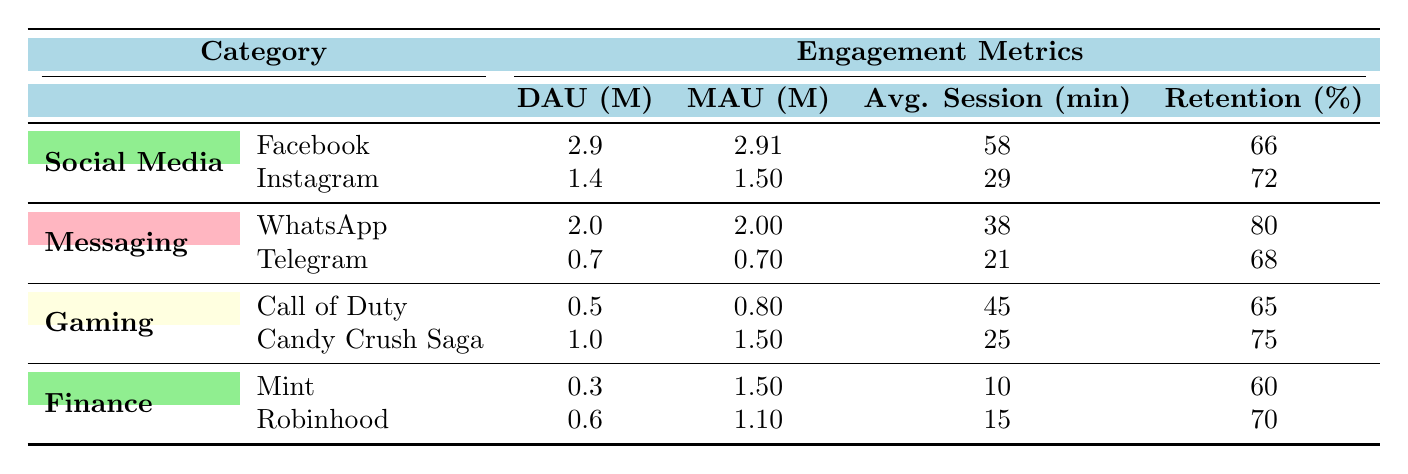What app has the highest Daily Active Users? By comparing the Daily Active Users values in the table, WhatsApp has the highest value with 2.0 million.
Answer: WhatsApp What is the average session duration for Instagram? The table shows the Average Session Duration for Instagram is listed as 29 minutes.
Answer: 29 minutes Which app has the lowest retention rate? By reviewing the Retention Rate values, Mint has the lowest rate at 60%.
Answer: Mint What is the total number of Monthly Active Users (MAU) for Social Media apps? The MAU for Facebook is 2.91 million and for Instagram is 1.50 million. Adding these gives 2.91 + 1.50 = 4.41 million.
Answer: 4.41 million Is the Average Session Duration for Robinhood greater than Mint? The Average Session Duration for Robinhood is 15 minutes, and for Mint, it is 10 minutes. Since 15 is greater than 10, the statement is true.
Answer: Yes What is the average retention rate for Finance apps? The retention rates for Mint and Robinhood are 60% and 70%, respectively. Adding these rates gives 60 + 70 = 130%, and dividing by 2 gives an average of 65%.
Answer: 65% Which category has the highest total Daily Active Users when combining all apps? The Daily Active Users for the categories are: Social Media (2.9 + 1.4), Messaging (2.0 + 0.7), Gaming (0.5 + 1.0), and Finance (0.3 + 0.6). Summing these gives Social Media: 4.3, Messaging: 2.7, Gaming: 1.5, and Finance: 0.9. The highest is Social Media at 4.3 million.
Answer: Social Media Which app in the Gaming category has a higher Monthly Active User count than its Daily Active User count? For Call of Duty, the figures are 0.5 million DAU and 0.8 million MAU, and for Candy Crush Saga, it's 1.0 million DAU and 1.5 million MAU. Both have a higher MAU than DAU, so both apps satisfy this condition.
Answer: Call of Duty and Candy Crush Saga What is the total Daily Active Users across Messaging apps? The Daily Active Users for WhatsApp is 2.0 million and for Telegram is 0.7 million. Adding these gives 2.0 + 0.7 = 2.7 million.
Answer: 2.7 million 